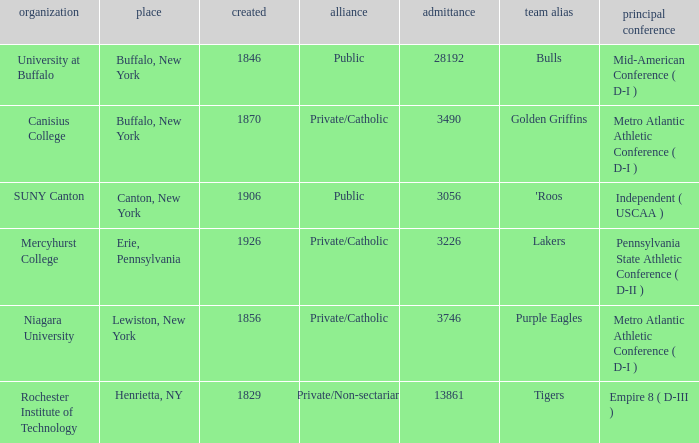What affiliation is Erie, Pennsylvania? Private/Catholic. 